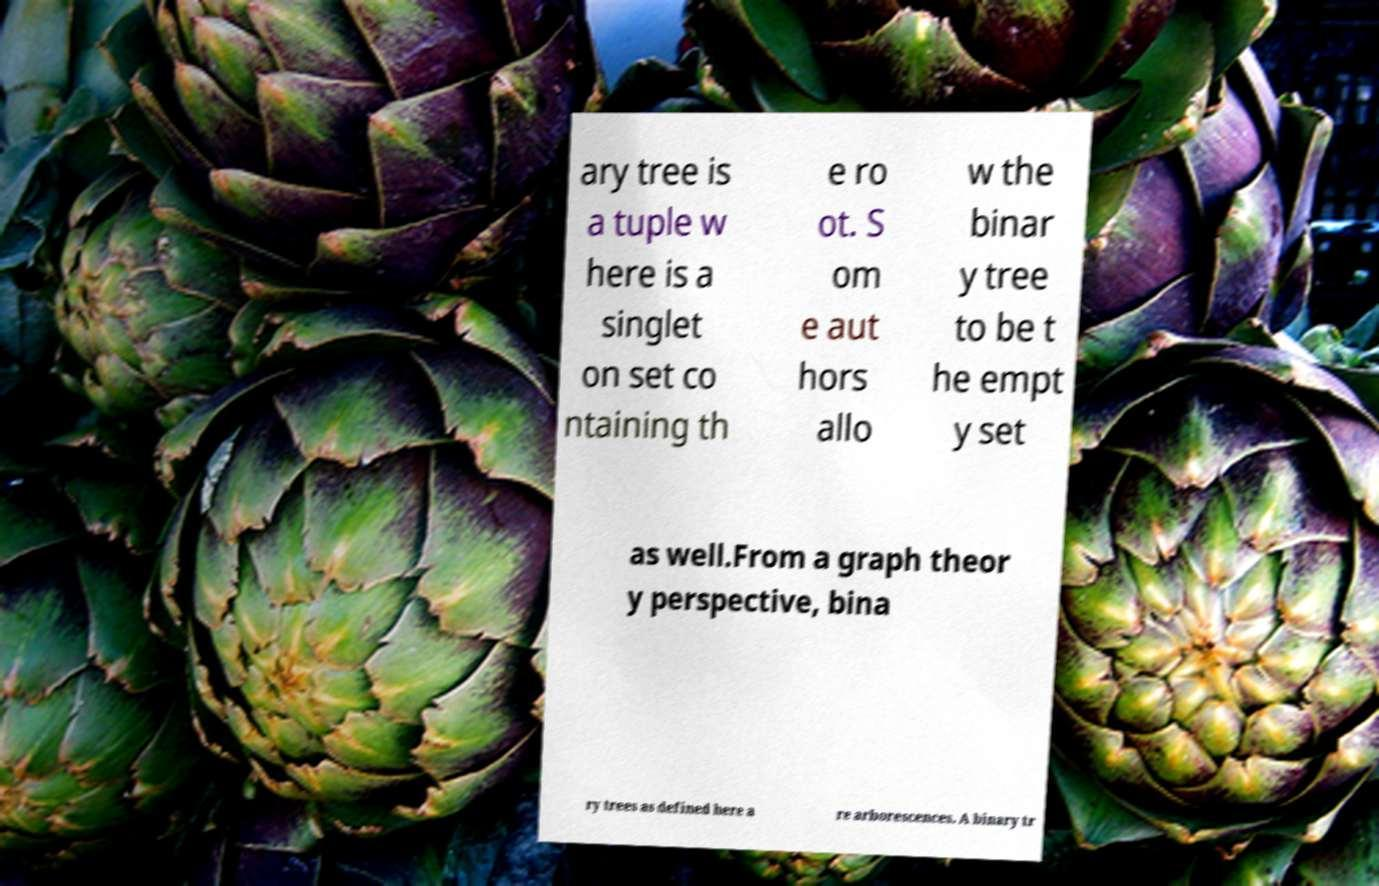There's text embedded in this image that I need extracted. Can you transcribe it verbatim? ary tree is a tuple w here is a singlet on set co ntaining th e ro ot. S om e aut hors allo w the binar y tree to be t he empt y set as well.From a graph theor y perspective, bina ry trees as defined here a re arborescences. A binary tr 